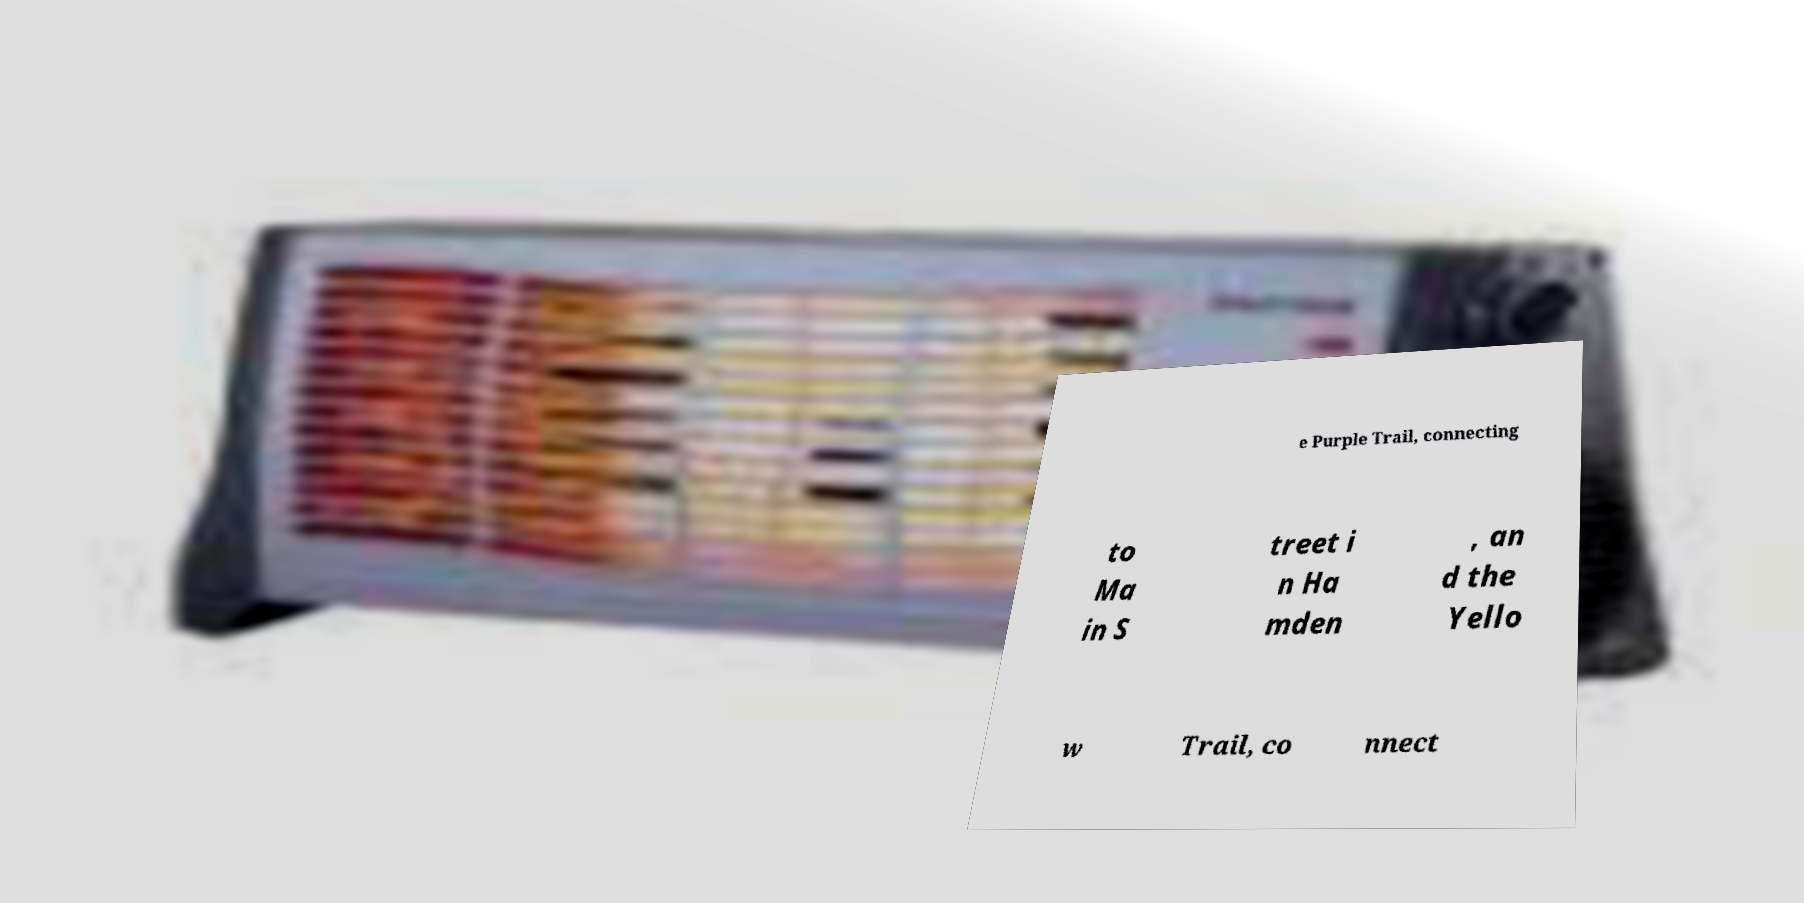Could you assist in decoding the text presented in this image and type it out clearly? e Purple Trail, connecting to Ma in S treet i n Ha mden , an d the Yello w Trail, co nnect 